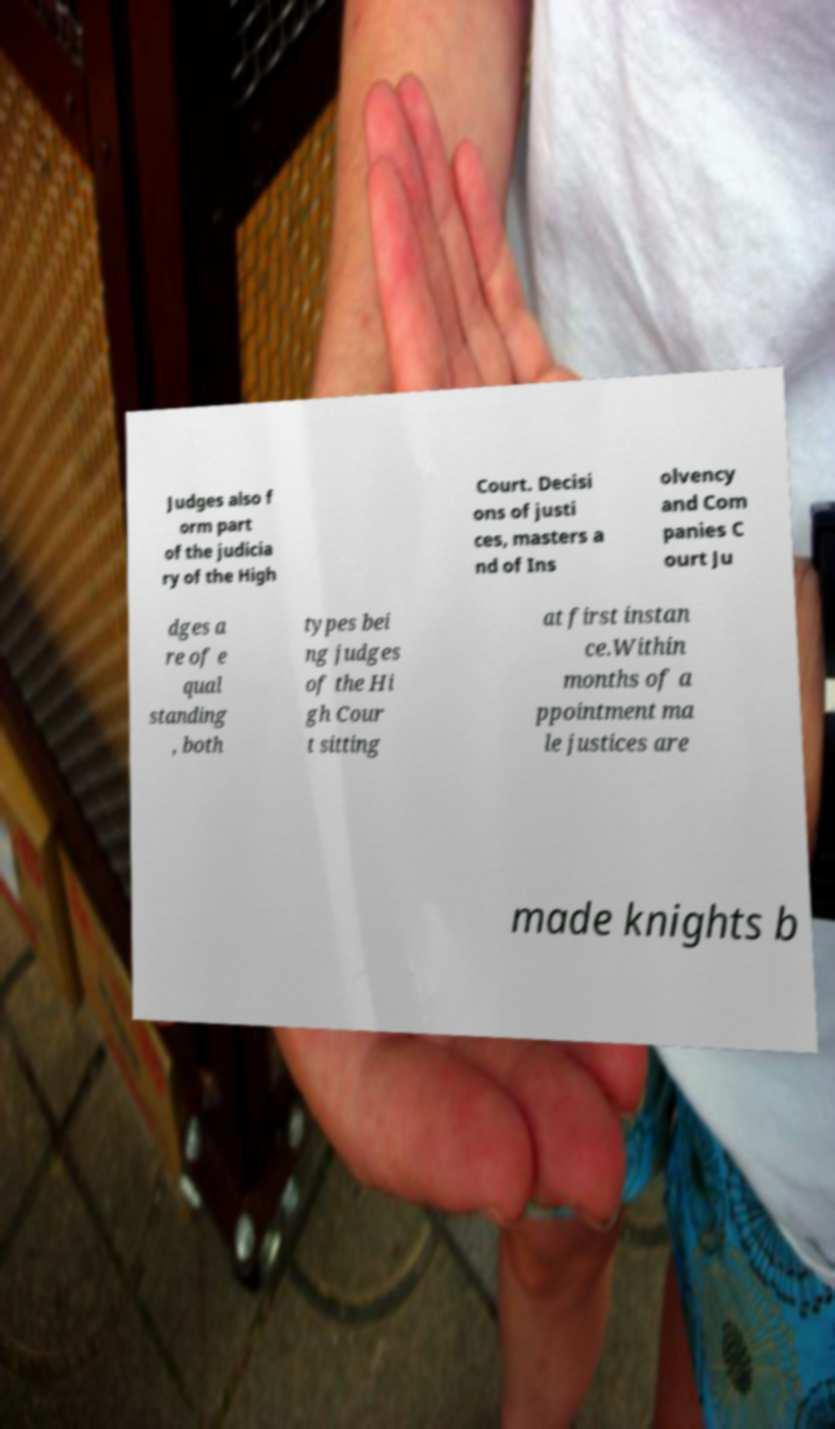Please read and relay the text visible in this image. What does it say? Judges also f orm part of the judicia ry of the High Court. Decisi ons of justi ces, masters a nd of Ins olvency and Com panies C ourt Ju dges a re of e qual standing , both types bei ng judges of the Hi gh Cour t sitting at first instan ce.Within months of a ppointment ma le justices are made knights b 